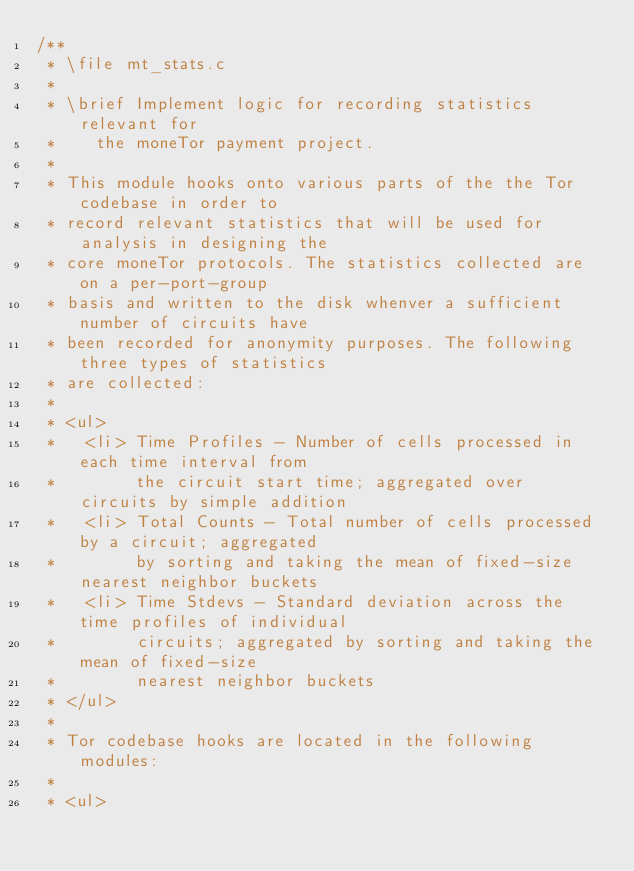Convert code to text. <code><loc_0><loc_0><loc_500><loc_500><_C_>/**
 * \file mt_stats.c
 *
 * \brief Implement logic for recording statistics relevant for
 *    the moneTor payment project.
 *
 * This module hooks onto various parts of the the Tor codebase in order to
 * record relevant statistics that will be used for analysis in designing the
 * core moneTor protocols. The statistics collected are on a per-port-group
 * basis and written to the disk whenver a sufficient number of circuits have
 * been recorded for anonymity purposes. The following three types of statistics
 * are collected:
 *
 * <ul>
 *   <li> Time Profiles - Number of cells processed in each time interval from
 *        the circuit start time; aggregated over circuits by simple addition
 *   <li> Total Counts - Total number of cells processed by a circuit; aggregated
 *        by sorting and taking the mean of fixed-size nearest neighbor buckets
 *   <li> Time Stdevs - Standard deviation across the time profiles of individual
 *        circuits; aggregated by sorting and taking the mean of fixed-size
 *        nearest neighbor buckets
 * </ul>
 *
 * Tor codebase hooks are located in the following modules:
 *
 * <ul></code> 